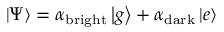<formula> <loc_0><loc_0><loc_500><loc_500>\left | \Psi \right \rangle = \alpha _ { b r i g h t } \left | g \right \rangle + \alpha _ { d a r k } \left | e \right \rangle</formula> 